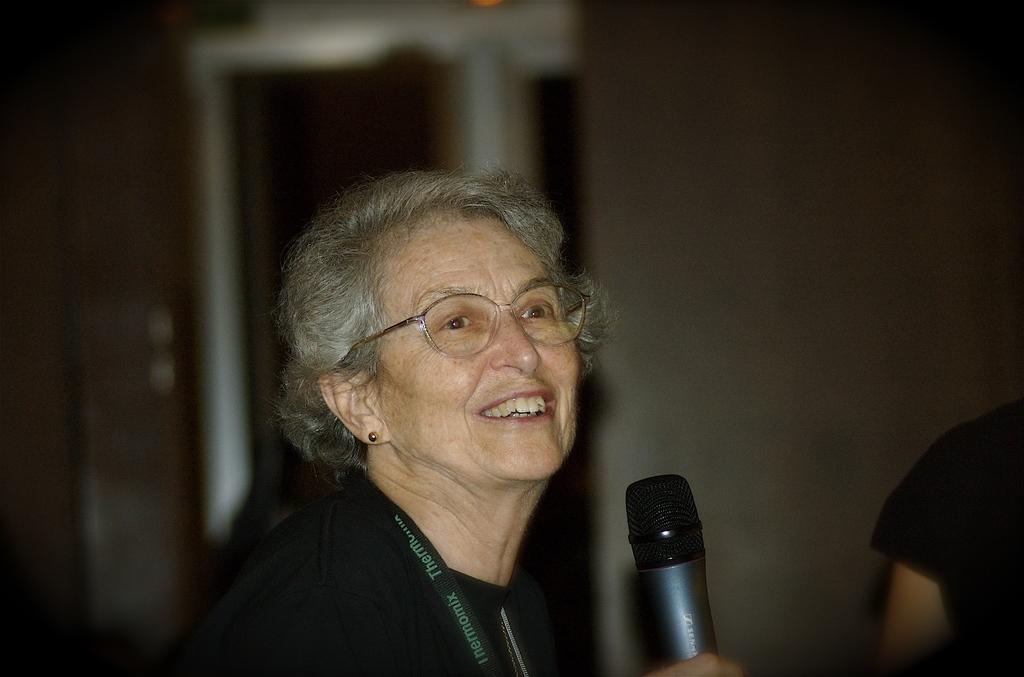Describe this image in one or two sentences. In this image an old woman is holding mic with a smiling face. Here there is another person. The background is blurry. 